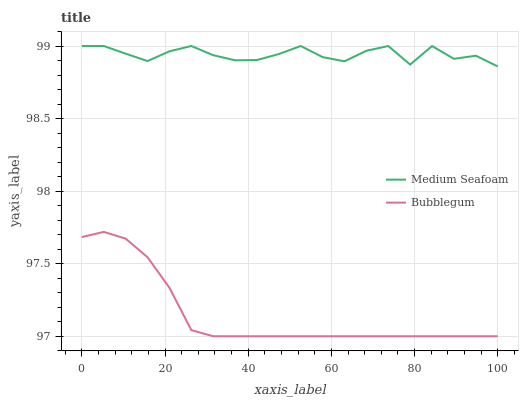Does Bubblegum have the minimum area under the curve?
Answer yes or no. Yes. Does Medium Seafoam have the maximum area under the curve?
Answer yes or no. Yes. Does Bubblegum have the maximum area under the curve?
Answer yes or no. No. Is Bubblegum the smoothest?
Answer yes or no. Yes. Is Medium Seafoam the roughest?
Answer yes or no. Yes. Is Bubblegum the roughest?
Answer yes or no. No. Does Bubblegum have the lowest value?
Answer yes or no. Yes. Does Medium Seafoam have the highest value?
Answer yes or no. Yes. Does Bubblegum have the highest value?
Answer yes or no. No. Is Bubblegum less than Medium Seafoam?
Answer yes or no. Yes. Is Medium Seafoam greater than Bubblegum?
Answer yes or no. Yes. Does Bubblegum intersect Medium Seafoam?
Answer yes or no. No. 